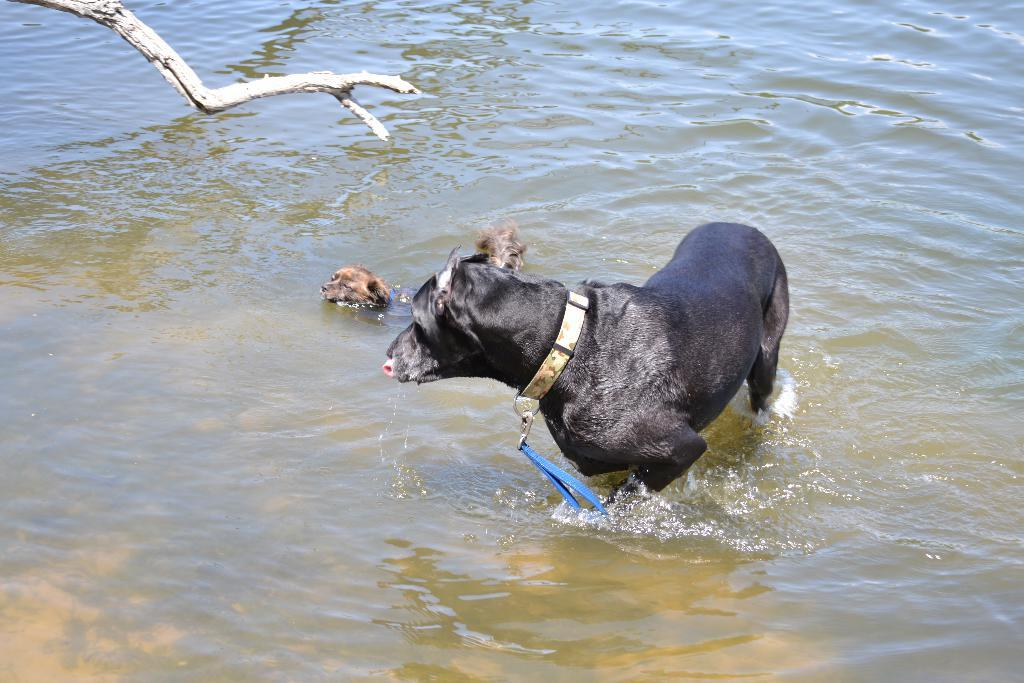What animals can be seen in the water in the image? There are two dogs in the water. What object is located on the left side of the image? There is a wooden trunk on the left side of the image. What type of stove can be seen in the image? There is no stove present in the image. How many nuts are visible in the image? There are no nuts present in the image. 